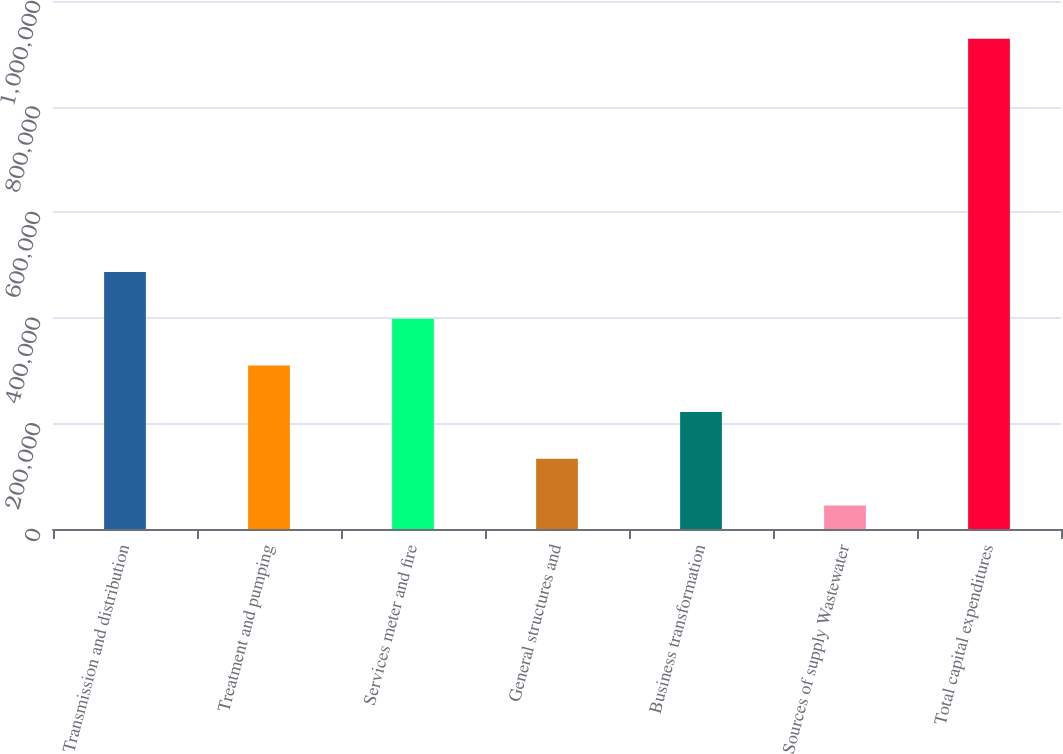<chart> <loc_0><loc_0><loc_500><loc_500><bar_chart><fcel>Transmission and distribution<fcel>Treatment and pumping<fcel>Services meter and fire<fcel>General structures and<fcel>Business transformation<fcel>Sources of supply Wastewater<fcel>Total capital expenditures<nl><fcel>486588<fcel>309794<fcel>398191<fcel>132999<fcel>221396<fcel>44602<fcel>928574<nl></chart> 